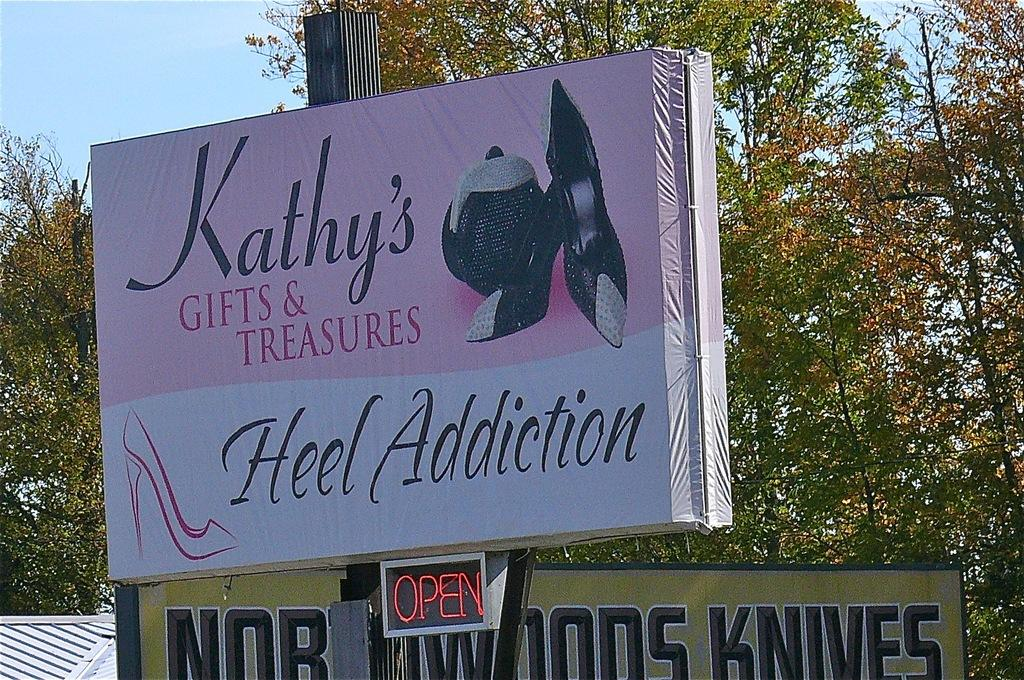<image>
Render a clear and concise summary of the photo. A sign for Kathy's gifts and treasures that says heel addiction. 